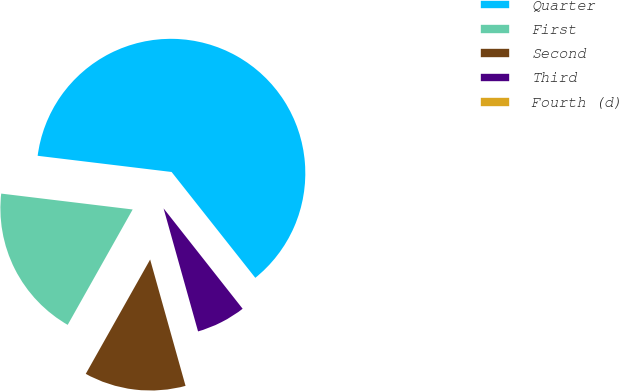Convert chart. <chart><loc_0><loc_0><loc_500><loc_500><pie_chart><fcel>Quarter<fcel>First<fcel>Second<fcel>Third<fcel>Fourth (d)<nl><fcel>62.43%<fcel>18.75%<fcel>12.51%<fcel>6.27%<fcel>0.03%<nl></chart> 